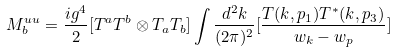Convert formula to latex. <formula><loc_0><loc_0><loc_500><loc_500>M _ { b } ^ { u u } = \frac { i g ^ { 4 } } { 2 } [ T ^ { a } T ^ { b } \otimes T _ { a } T _ { b } ] \int \frac { d ^ { 2 } k } { ( 2 \pi ) ^ { 2 } } [ \frac { T ( k , p _ { 1 } ) T ^ { * } ( k , p _ { 3 } ) } { w _ { k } - w _ { p } } ]</formula> 